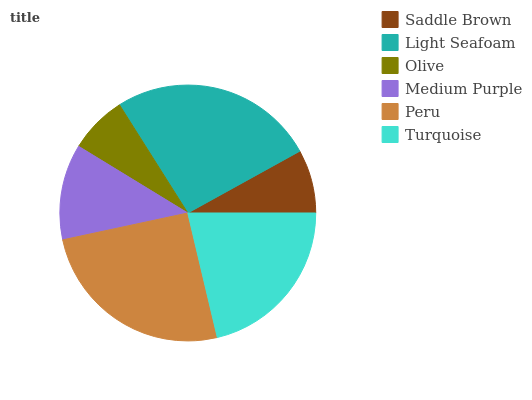Is Olive the minimum?
Answer yes or no. Yes. Is Light Seafoam the maximum?
Answer yes or no. Yes. Is Light Seafoam the minimum?
Answer yes or no. No. Is Olive the maximum?
Answer yes or no. No. Is Light Seafoam greater than Olive?
Answer yes or no. Yes. Is Olive less than Light Seafoam?
Answer yes or no. Yes. Is Olive greater than Light Seafoam?
Answer yes or no. No. Is Light Seafoam less than Olive?
Answer yes or no. No. Is Turquoise the high median?
Answer yes or no. Yes. Is Medium Purple the low median?
Answer yes or no. Yes. Is Saddle Brown the high median?
Answer yes or no. No. Is Peru the low median?
Answer yes or no. No. 